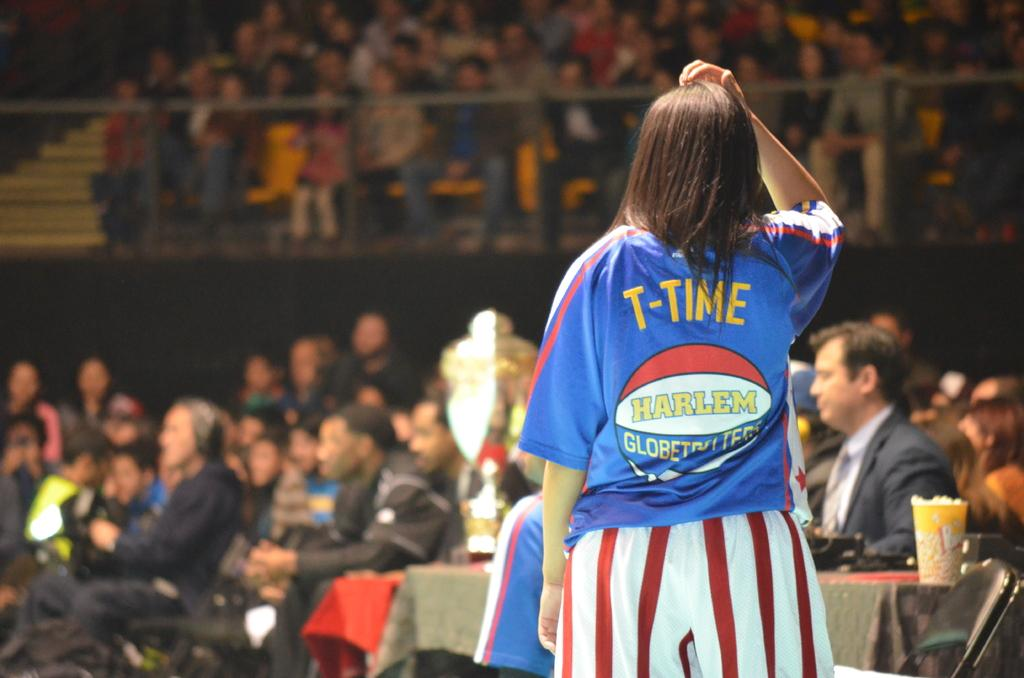<image>
Offer a succinct explanation of the picture presented. A person is standing in front of a crowd with the wording T-TIME on the back of her shirt. 